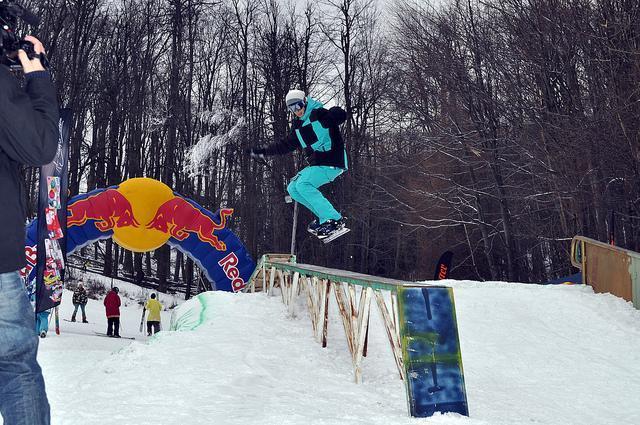How many people can be seen?
Give a very brief answer. 2. 